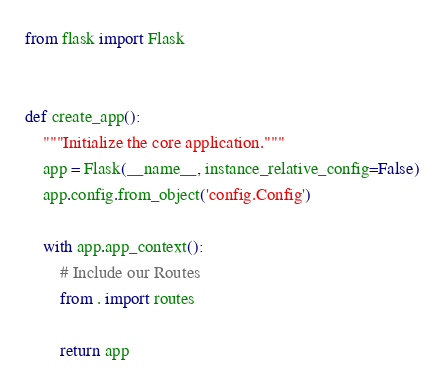Convert code to text. <code><loc_0><loc_0><loc_500><loc_500><_Python_>from flask import Flask


def create_app():
    """Initialize the core application."""
    app = Flask(__name__, instance_relative_config=False)
    app.config.from_object('config.Config')

    with app.app_context():
        # Include our Routes
        from . import routes

        return app
</code> 